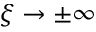<formula> <loc_0><loc_0><loc_500><loc_500>\xi \to \pm \infty</formula> 